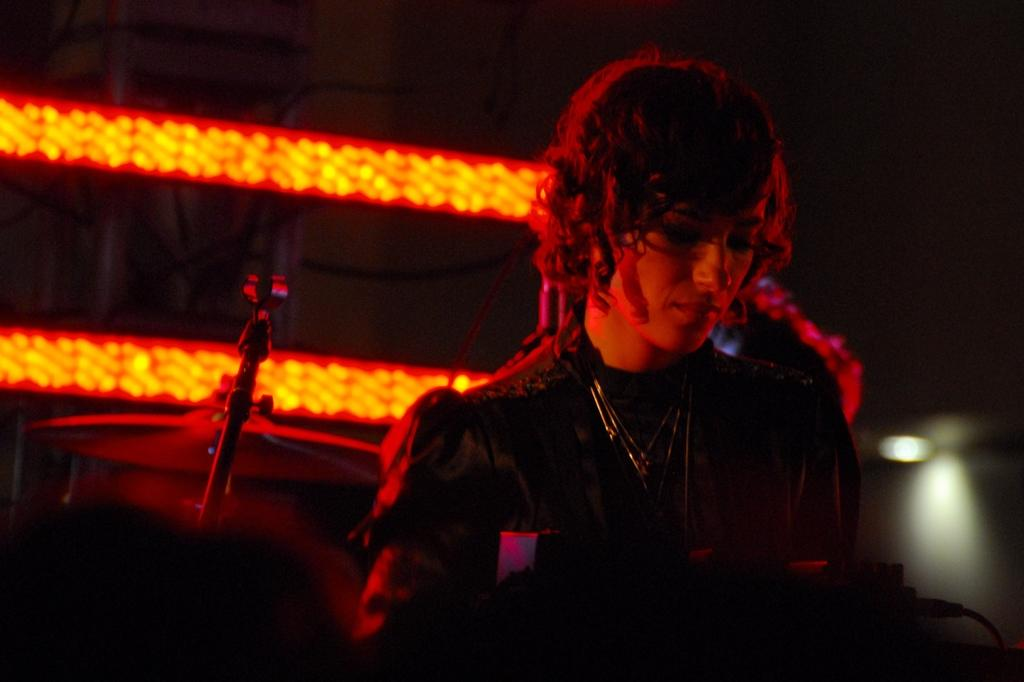What is the main subject of the image? There is a person in the image. What can be seen in the background of the image? There are musical instruments in the background of the image. What else is visible in the image? There are lights visible in the image. Can you tell me how many snakes are slithering on the person's feet in the image? There are no snakes present in the image; the person's feet are not visible. What type of bear can be seen playing the musical instruments in the background? There is no bear present in the image, and the musical instruments are not being played by any animals. 